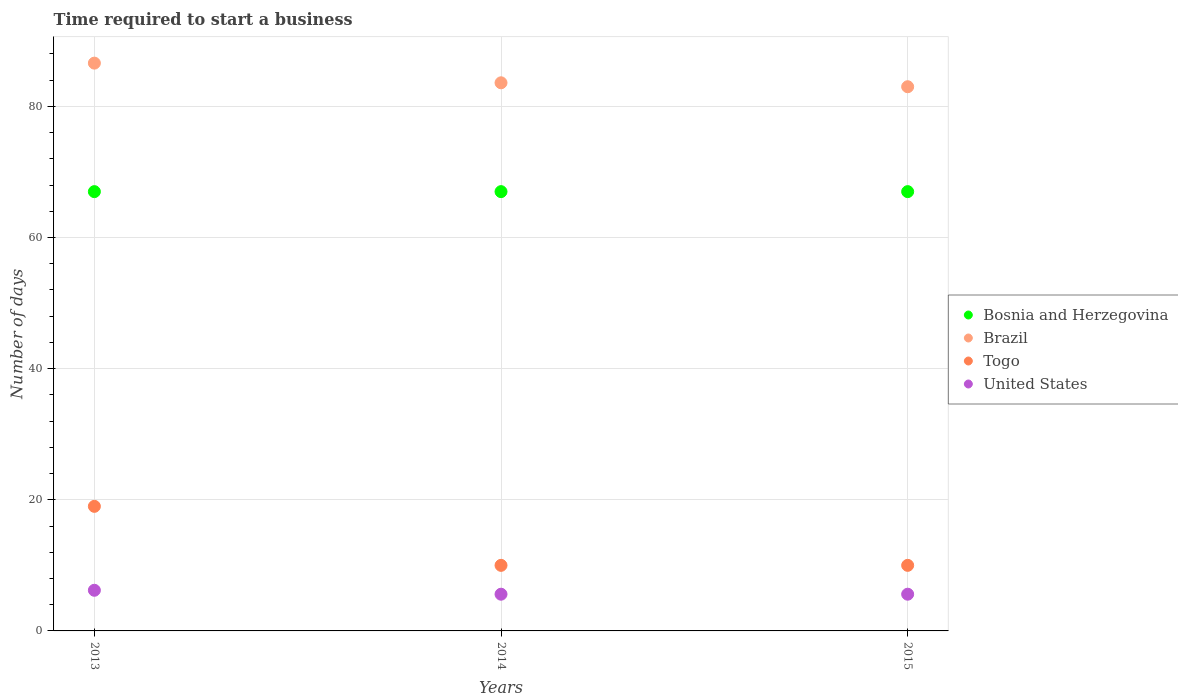How many different coloured dotlines are there?
Provide a succinct answer. 4. What is the number of days required to start a business in Brazil in 2013?
Give a very brief answer. 86.6. Across all years, what is the maximum number of days required to start a business in Brazil?
Offer a terse response. 86.6. In which year was the number of days required to start a business in Brazil maximum?
Make the answer very short. 2013. What is the total number of days required to start a business in Togo in the graph?
Offer a very short reply. 39. What is the difference between the number of days required to start a business in Brazil in 2013 and that in 2015?
Offer a terse response. 3.6. What is the difference between the number of days required to start a business in United States in 2013 and the number of days required to start a business in Bosnia and Herzegovina in 2014?
Your answer should be compact. -60.8. What is the average number of days required to start a business in Togo per year?
Give a very brief answer. 13. In the year 2013, what is the difference between the number of days required to start a business in Bosnia and Herzegovina and number of days required to start a business in Brazil?
Provide a succinct answer. -19.6. In how many years, is the number of days required to start a business in United States greater than 32 days?
Offer a very short reply. 0. Is the number of days required to start a business in United States in 2014 less than that in 2015?
Offer a terse response. No. Is the difference between the number of days required to start a business in Bosnia and Herzegovina in 2013 and 2015 greater than the difference between the number of days required to start a business in Brazil in 2013 and 2015?
Your answer should be very brief. No. What is the difference between the highest and the second highest number of days required to start a business in Bosnia and Herzegovina?
Give a very brief answer. 0. What is the difference between the highest and the lowest number of days required to start a business in Brazil?
Offer a terse response. 3.6. Does the number of days required to start a business in United States monotonically increase over the years?
Offer a terse response. No. Is the number of days required to start a business in United States strictly greater than the number of days required to start a business in Brazil over the years?
Make the answer very short. No. Is the number of days required to start a business in Togo strictly less than the number of days required to start a business in United States over the years?
Offer a very short reply. No. How many years are there in the graph?
Your response must be concise. 3. Does the graph contain any zero values?
Your answer should be very brief. No. Does the graph contain grids?
Provide a short and direct response. Yes. What is the title of the graph?
Offer a terse response. Time required to start a business. Does "Peru" appear as one of the legend labels in the graph?
Give a very brief answer. No. What is the label or title of the X-axis?
Your answer should be very brief. Years. What is the label or title of the Y-axis?
Offer a very short reply. Number of days. What is the Number of days of Brazil in 2013?
Provide a short and direct response. 86.6. What is the Number of days of Togo in 2013?
Make the answer very short. 19. What is the Number of days in United States in 2013?
Provide a succinct answer. 6.2. What is the Number of days in Brazil in 2014?
Give a very brief answer. 83.6. What is the Number of days of Togo in 2014?
Keep it short and to the point. 10. What is the Number of days of United States in 2014?
Make the answer very short. 5.6. What is the Number of days in Bosnia and Herzegovina in 2015?
Ensure brevity in your answer.  67. What is the Number of days of Brazil in 2015?
Your answer should be very brief. 83. What is the Number of days in United States in 2015?
Offer a terse response. 5.6. Across all years, what is the maximum Number of days in Brazil?
Your response must be concise. 86.6. Across all years, what is the minimum Number of days of Bosnia and Herzegovina?
Your answer should be very brief. 67. Across all years, what is the minimum Number of days of Brazil?
Provide a short and direct response. 83. Across all years, what is the minimum Number of days of Togo?
Your answer should be compact. 10. Across all years, what is the minimum Number of days in United States?
Provide a succinct answer. 5.6. What is the total Number of days in Bosnia and Herzegovina in the graph?
Make the answer very short. 201. What is the total Number of days of Brazil in the graph?
Provide a succinct answer. 253.2. What is the total Number of days in Togo in the graph?
Provide a succinct answer. 39. What is the difference between the Number of days in Bosnia and Herzegovina in 2013 and that in 2014?
Keep it short and to the point. 0. What is the difference between the Number of days of Brazil in 2013 and that in 2014?
Offer a terse response. 3. What is the difference between the Number of days in Togo in 2013 and that in 2014?
Your response must be concise. 9. What is the difference between the Number of days of Brazil in 2013 and that in 2015?
Make the answer very short. 3.6. What is the difference between the Number of days of Togo in 2013 and that in 2015?
Your answer should be compact. 9. What is the difference between the Number of days in United States in 2013 and that in 2015?
Make the answer very short. 0.6. What is the difference between the Number of days of Bosnia and Herzegovina in 2014 and that in 2015?
Give a very brief answer. 0. What is the difference between the Number of days in Brazil in 2014 and that in 2015?
Keep it short and to the point. 0.6. What is the difference between the Number of days of United States in 2014 and that in 2015?
Keep it short and to the point. 0. What is the difference between the Number of days of Bosnia and Herzegovina in 2013 and the Number of days of Brazil in 2014?
Provide a short and direct response. -16.6. What is the difference between the Number of days of Bosnia and Herzegovina in 2013 and the Number of days of Togo in 2014?
Make the answer very short. 57. What is the difference between the Number of days in Bosnia and Herzegovina in 2013 and the Number of days in United States in 2014?
Provide a short and direct response. 61.4. What is the difference between the Number of days of Brazil in 2013 and the Number of days of Togo in 2014?
Ensure brevity in your answer.  76.6. What is the difference between the Number of days of Togo in 2013 and the Number of days of United States in 2014?
Provide a succinct answer. 13.4. What is the difference between the Number of days in Bosnia and Herzegovina in 2013 and the Number of days in United States in 2015?
Your response must be concise. 61.4. What is the difference between the Number of days of Brazil in 2013 and the Number of days of Togo in 2015?
Ensure brevity in your answer.  76.6. What is the difference between the Number of days in Bosnia and Herzegovina in 2014 and the Number of days in Brazil in 2015?
Ensure brevity in your answer.  -16. What is the difference between the Number of days in Bosnia and Herzegovina in 2014 and the Number of days in United States in 2015?
Your response must be concise. 61.4. What is the difference between the Number of days of Brazil in 2014 and the Number of days of Togo in 2015?
Your answer should be very brief. 73.6. What is the difference between the Number of days of Brazil in 2014 and the Number of days of United States in 2015?
Your answer should be very brief. 78. What is the difference between the Number of days of Togo in 2014 and the Number of days of United States in 2015?
Your answer should be very brief. 4.4. What is the average Number of days in Bosnia and Herzegovina per year?
Your answer should be very brief. 67. What is the average Number of days of Brazil per year?
Make the answer very short. 84.4. What is the average Number of days of United States per year?
Provide a succinct answer. 5.8. In the year 2013, what is the difference between the Number of days of Bosnia and Herzegovina and Number of days of Brazil?
Your answer should be very brief. -19.6. In the year 2013, what is the difference between the Number of days of Bosnia and Herzegovina and Number of days of United States?
Your answer should be very brief. 60.8. In the year 2013, what is the difference between the Number of days of Brazil and Number of days of Togo?
Your response must be concise. 67.6. In the year 2013, what is the difference between the Number of days of Brazil and Number of days of United States?
Offer a very short reply. 80.4. In the year 2014, what is the difference between the Number of days of Bosnia and Herzegovina and Number of days of Brazil?
Ensure brevity in your answer.  -16.6. In the year 2014, what is the difference between the Number of days of Bosnia and Herzegovina and Number of days of Togo?
Make the answer very short. 57. In the year 2014, what is the difference between the Number of days of Bosnia and Herzegovina and Number of days of United States?
Offer a very short reply. 61.4. In the year 2014, what is the difference between the Number of days of Brazil and Number of days of Togo?
Your response must be concise. 73.6. In the year 2015, what is the difference between the Number of days of Bosnia and Herzegovina and Number of days of Brazil?
Your answer should be very brief. -16. In the year 2015, what is the difference between the Number of days in Bosnia and Herzegovina and Number of days in United States?
Your answer should be compact. 61.4. In the year 2015, what is the difference between the Number of days in Brazil and Number of days in Togo?
Provide a succinct answer. 73. In the year 2015, what is the difference between the Number of days of Brazil and Number of days of United States?
Make the answer very short. 77.4. In the year 2015, what is the difference between the Number of days in Togo and Number of days in United States?
Your answer should be very brief. 4.4. What is the ratio of the Number of days of Bosnia and Herzegovina in 2013 to that in 2014?
Ensure brevity in your answer.  1. What is the ratio of the Number of days in Brazil in 2013 to that in 2014?
Ensure brevity in your answer.  1.04. What is the ratio of the Number of days of Togo in 2013 to that in 2014?
Provide a short and direct response. 1.9. What is the ratio of the Number of days in United States in 2013 to that in 2014?
Ensure brevity in your answer.  1.11. What is the ratio of the Number of days in Brazil in 2013 to that in 2015?
Offer a terse response. 1.04. What is the ratio of the Number of days of United States in 2013 to that in 2015?
Offer a very short reply. 1.11. What is the ratio of the Number of days of Brazil in 2014 to that in 2015?
Make the answer very short. 1.01. What is the difference between the highest and the second highest Number of days in Bosnia and Herzegovina?
Give a very brief answer. 0. What is the difference between the highest and the second highest Number of days in Brazil?
Keep it short and to the point. 3. What is the difference between the highest and the second highest Number of days in United States?
Keep it short and to the point. 0.6. What is the difference between the highest and the lowest Number of days of Brazil?
Your response must be concise. 3.6. What is the difference between the highest and the lowest Number of days of United States?
Provide a short and direct response. 0.6. 